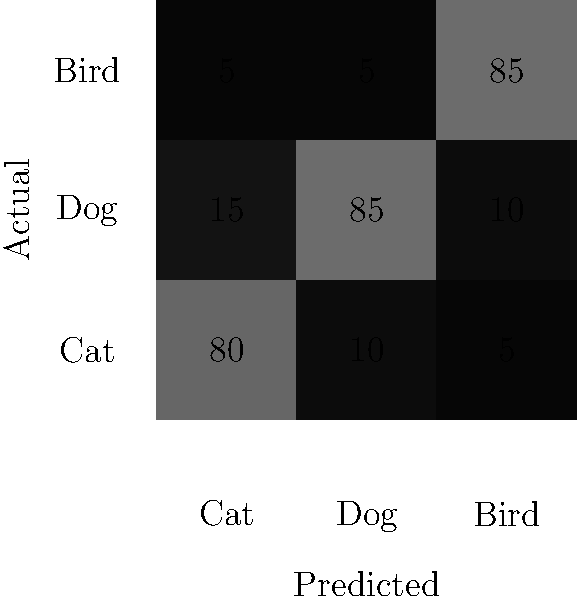As a Mercurial user familiar with version control systems, you're working on a machine learning project for image classification. Given the confusion matrix above for a multi-class image classification problem (Cat, Dog, Bird), what is the overall accuracy of the model? To calculate the overall accuracy of the model, we need to follow these steps:

1. Identify the total number of correct predictions:
   - Correct predictions are on the diagonal of the matrix
   - Cat: 80
   - Dog: 85
   - Bird: 85
   - Total correct predictions = 80 + 85 + 85 = 250

2. Calculate the total number of predictions:
   - Sum all values in the matrix
   - (80 + 15 + 5) + (10 + 85 + 5) + (5 + 10 + 85) = 100 + 100 + 100 = 300

3. Calculate the accuracy:
   - Accuracy = (Number of correct predictions) / (Total number of predictions)
   - Accuracy = 250 / 300

4. Convert to a percentage:
   - Accuracy = (250 / 300) * 100 = 83.33%

Therefore, the overall accuracy of the model is approximately 83.33%.
Answer: 83.33% 